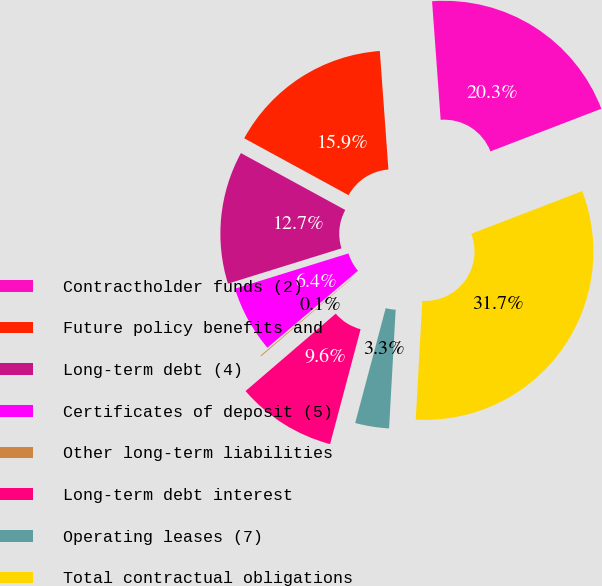Convert chart. <chart><loc_0><loc_0><loc_500><loc_500><pie_chart><fcel>Contractholder funds (2)<fcel>Future policy benefits and<fcel>Long-term debt (4)<fcel>Certificates of deposit (5)<fcel>Other long-term liabilities<fcel>Long-term debt interest<fcel>Operating leases (7)<fcel>Total contractual obligations<nl><fcel>20.31%<fcel>15.9%<fcel>12.74%<fcel>6.41%<fcel>0.08%<fcel>9.58%<fcel>3.25%<fcel>31.72%<nl></chart> 